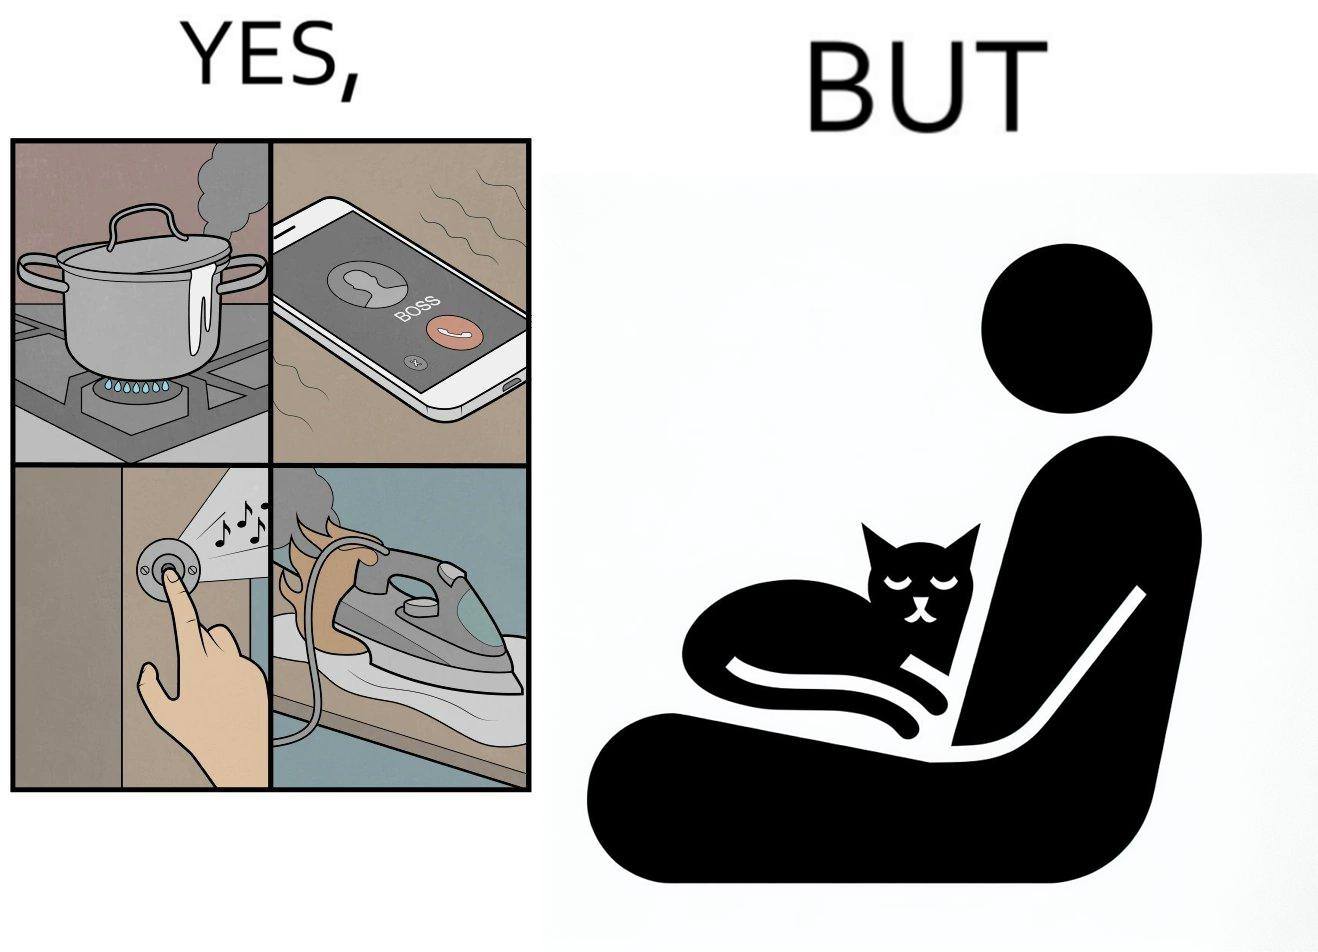Why is this image considered satirical? the irony in this image is that people ignore all the chaos around them and get distracted by a cat. 